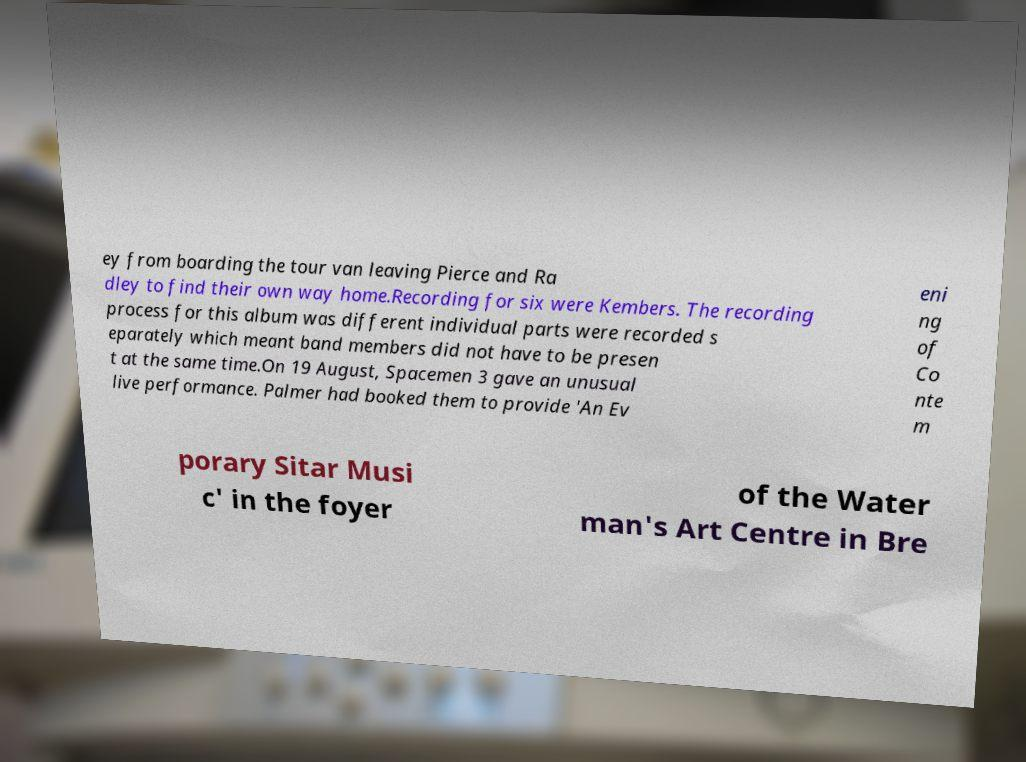There's text embedded in this image that I need extracted. Can you transcribe it verbatim? ey from boarding the tour van leaving Pierce and Ra dley to find their own way home.Recording for six were Kembers. The recording process for this album was different individual parts were recorded s eparately which meant band members did not have to be presen t at the same time.On 19 August, Spacemen 3 gave an unusual live performance. Palmer had booked them to provide 'An Ev eni ng of Co nte m porary Sitar Musi c' in the foyer of the Water man's Art Centre in Bre 